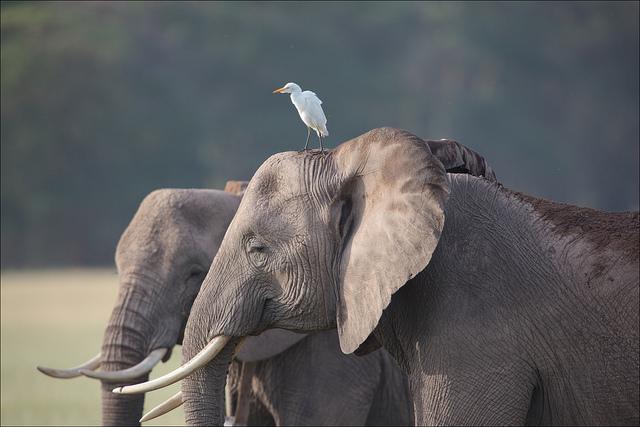What animal is perched on top of the elephant?
Give a very brief answer. Bird. Are the elephants moving?
Be succinct. No. Is the tusk whole or broken?
Quick response, please. Whole. Are these animals in the wild?
Short answer required. Yes. What does the bird eat?
Concise answer only. Bugs. 